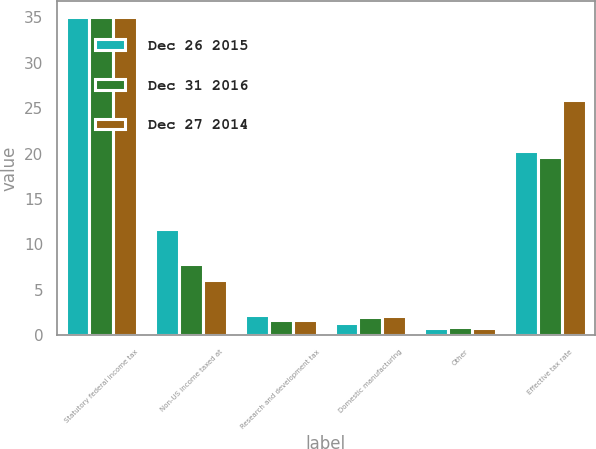Convert chart. <chart><loc_0><loc_0><loc_500><loc_500><stacked_bar_chart><ecel><fcel>Statutory federal income tax<fcel>Non-US income taxed at<fcel>Research and development tax<fcel>Domestic manufacturing<fcel>Other<fcel>Effective tax rate<nl><fcel>Dec 26 2015<fcel>35<fcel>11.7<fcel>2.3<fcel>1.4<fcel>0.8<fcel>20.3<nl><fcel>Dec 31 2016<fcel>35<fcel>7.9<fcel>1.7<fcel>2<fcel>0.9<fcel>19.6<nl><fcel>Dec 27 2014<fcel>35<fcel>6.1<fcel>1.7<fcel>2.1<fcel>0.8<fcel>25.9<nl></chart> 